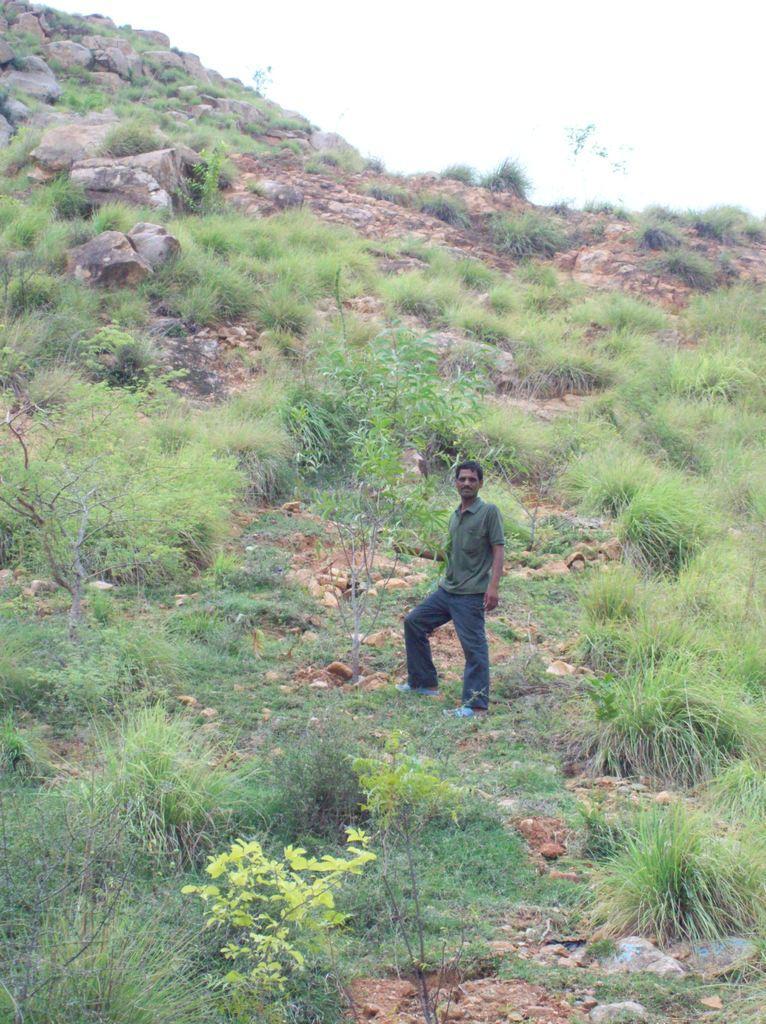Could you give a brief overview of what you see in this image? In this image we can see a person wearing gray color T-shirt is standing on the hill. Here we can see small plants, rocks on the hill and the sky in the background. 